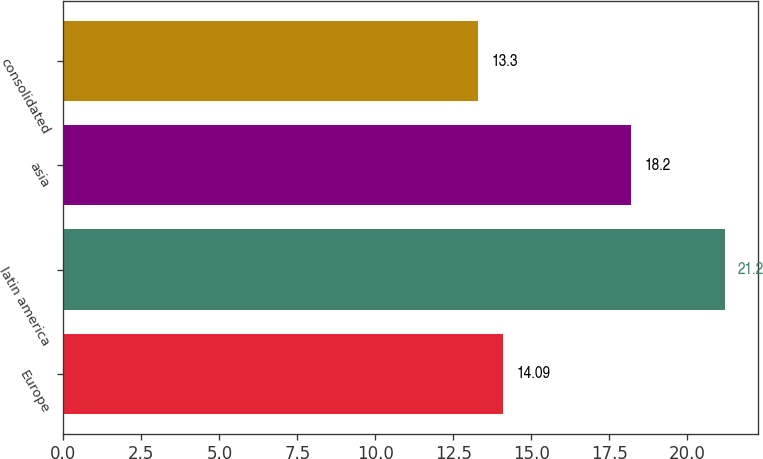Convert chart. <chart><loc_0><loc_0><loc_500><loc_500><bar_chart><fcel>Europe<fcel>latin america<fcel>asia<fcel>consolidated<nl><fcel>14.09<fcel>21.2<fcel>18.2<fcel>13.3<nl></chart> 